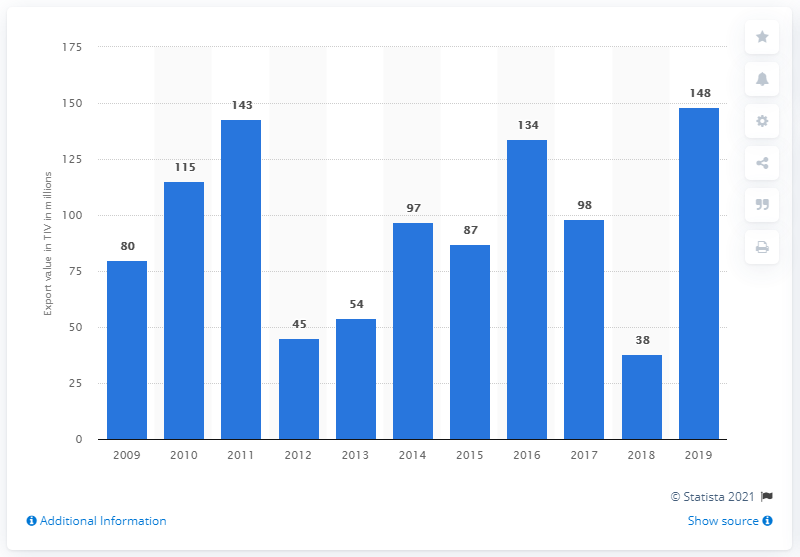Give some essential details in this illustration. In 2019, there were 148 Australian arms exports. 